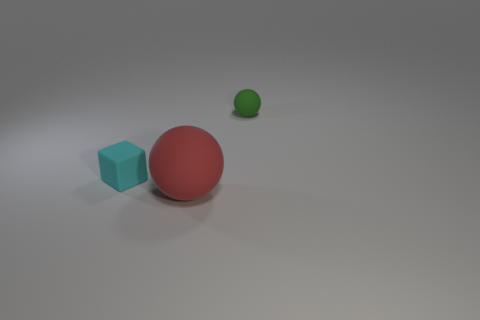Add 3 large brown metallic objects. How many objects exist? 6 Subtract all green spheres. How many spheres are left? 1 Subtract all cubes. How many objects are left? 2 Subtract 1 cyan blocks. How many objects are left? 2 Subtract 1 balls. How many balls are left? 1 Subtract all green spheres. Subtract all cyan blocks. How many spheres are left? 1 Subtract all red cubes. How many red spheres are left? 1 Subtract all small cubes. Subtract all large red rubber things. How many objects are left? 1 Add 1 tiny green balls. How many tiny green balls are left? 2 Add 1 large cyan matte things. How many large cyan matte things exist? 1 